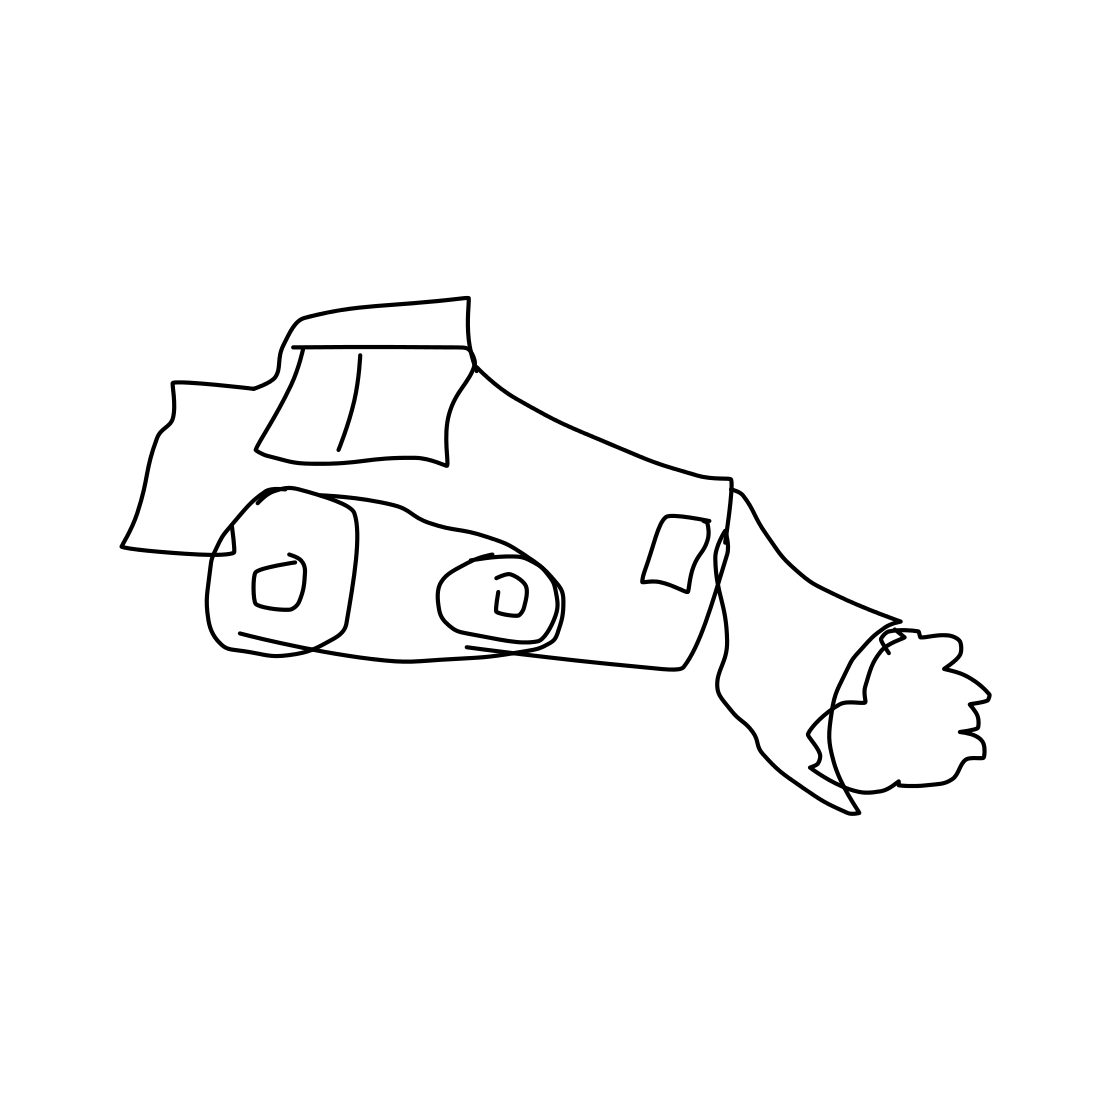Is there a sketchy grapes in the picture? No 